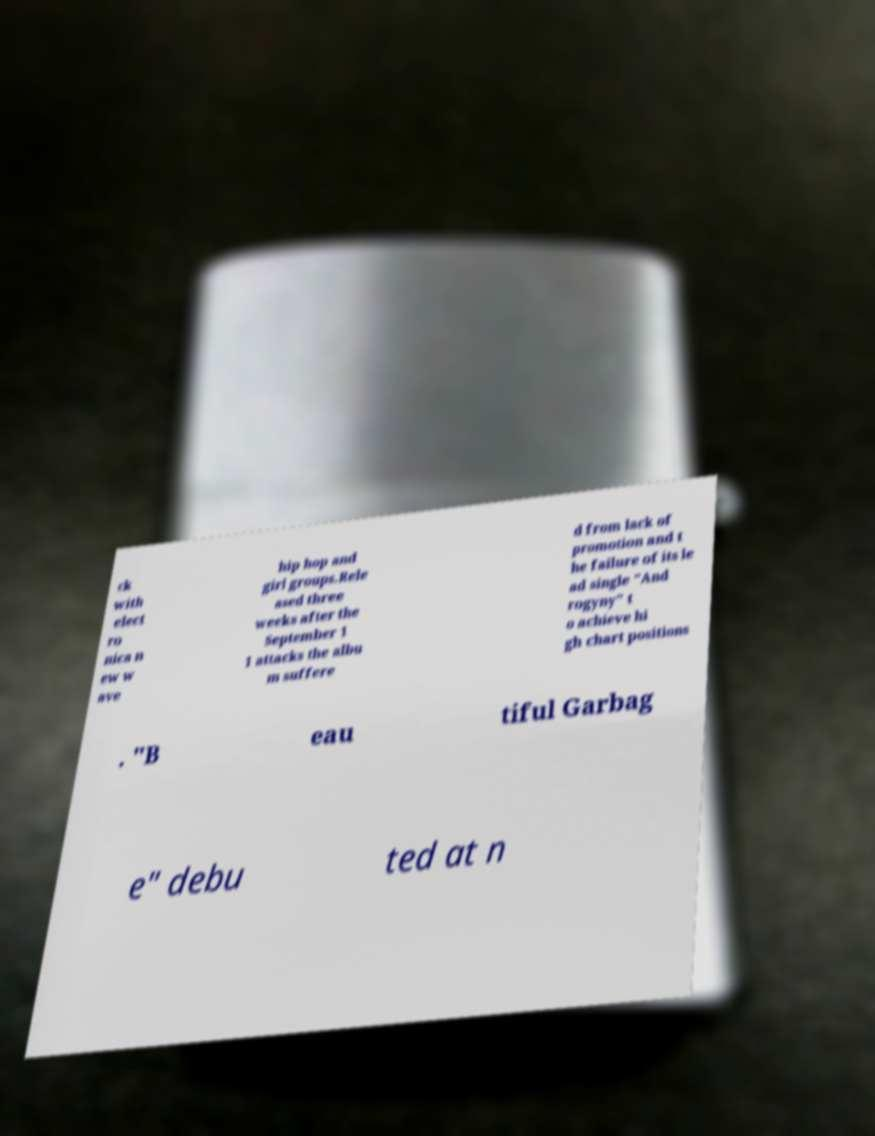Please read and relay the text visible in this image. What does it say? ck with elect ro nica n ew w ave hip hop and girl groups.Rele ased three weeks after the September 1 1 attacks the albu m suffere d from lack of promotion and t he failure of its le ad single "And rogyny" t o achieve hi gh chart positions . "B eau tiful Garbag e" debu ted at n 